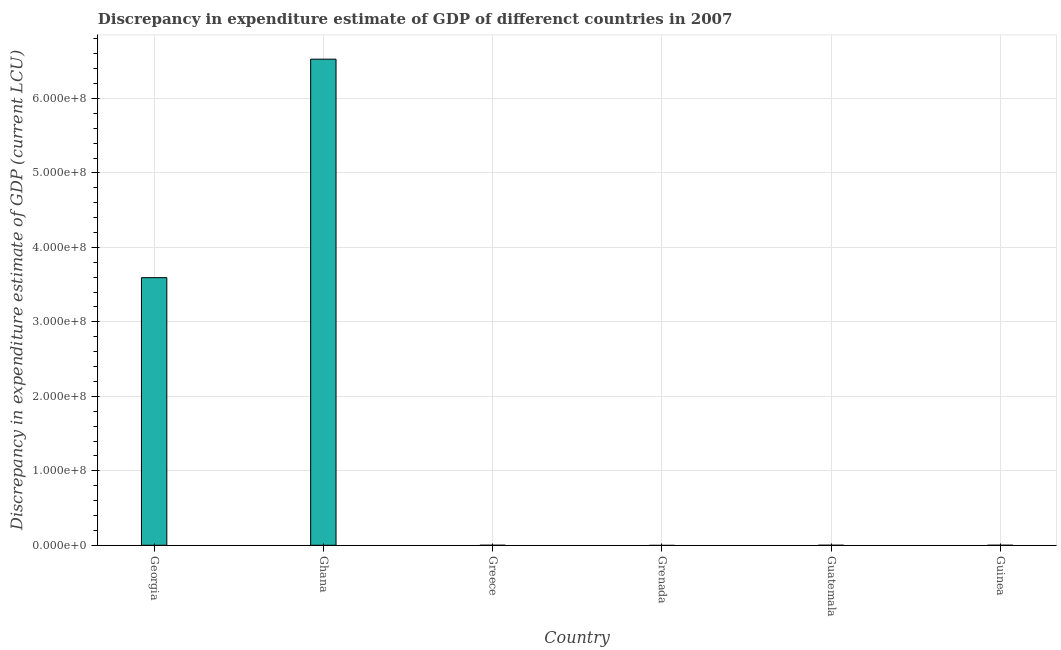What is the title of the graph?
Make the answer very short. Discrepancy in expenditure estimate of GDP of differenct countries in 2007. What is the label or title of the X-axis?
Give a very brief answer. Country. What is the label or title of the Y-axis?
Make the answer very short. Discrepancy in expenditure estimate of GDP (current LCU). Across all countries, what is the maximum discrepancy in expenditure estimate of gdp?
Your answer should be very brief. 6.53e+08. What is the sum of the discrepancy in expenditure estimate of gdp?
Offer a terse response. 1.01e+09. What is the difference between the discrepancy in expenditure estimate of gdp in Georgia and Greece?
Make the answer very short. 3.59e+08. What is the average discrepancy in expenditure estimate of gdp per country?
Your answer should be very brief. 1.69e+08. What is the median discrepancy in expenditure estimate of gdp?
Provide a succinct answer. 50. In how many countries, is the discrepancy in expenditure estimate of gdp greater than 600000000 LCU?
Make the answer very short. 1. What is the ratio of the discrepancy in expenditure estimate of gdp in Greece to that in Guatemala?
Offer a very short reply. 8.70e+05. Is the difference between the discrepancy in expenditure estimate of gdp in Georgia and Greece greater than the difference between any two countries?
Provide a short and direct response. No. What is the difference between the highest and the second highest discrepancy in expenditure estimate of gdp?
Offer a terse response. 2.93e+08. What is the difference between the highest and the lowest discrepancy in expenditure estimate of gdp?
Your response must be concise. 6.53e+08. What is the difference between two consecutive major ticks on the Y-axis?
Your answer should be compact. 1.00e+08. Are the values on the major ticks of Y-axis written in scientific E-notation?
Your answer should be very brief. Yes. What is the Discrepancy in expenditure estimate of GDP (current LCU) of Georgia?
Your answer should be very brief. 3.59e+08. What is the Discrepancy in expenditure estimate of GDP (current LCU) in Ghana?
Your answer should be compact. 6.53e+08. What is the Discrepancy in expenditure estimate of GDP (current LCU) in Guatemala?
Your answer should be compact. 0. What is the difference between the Discrepancy in expenditure estimate of GDP (current LCU) in Georgia and Ghana?
Your response must be concise. -2.93e+08. What is the difference between the Discrepancy in expenditure estimate of GDP (current LCU) in Georgia and Greece?
Offer a terse response. 3.59e+08. What is the difference between the Discrepancy in expenditure estimate of GDP (current LCU) in Georgia and Guatemala?
Offer a very short reply. 3.59e+08. What is the difference between the Discrepancy in expenditure estimate of GDP (current LCU) in Ghana and Greece?
Provide a succinct answer. 6.53e+08. What is the difference between the Discrepancy in expenditure estimate of GDP (current LCU) in Ghana and Guatemala?
Your response must be concise. 6.53e+08. What is the difference between the Discrepancy in expenditure estimate of GDP (current LCU) in Greece and Guatemala?
Give a very brief answer. 100. What is the ratio of the Discrepancy in expenditure estimate of GDP (current LCU) in Georgia to that in Ghana?
Make the answer very short. 0.55. What is the ratio of the Discrepancy in expenditure estimate of GDP (current LCU) in Georgia to that in Greece?
Your answer should be very brief. 3.59e+06. What is the ratio of the Discrepancy in expenditure estimate of GDP (current LCU) in Georgia to that in Guatemala?
Offer a terse response. 3.12e+12. What is the ratio of the Discrepancy in expenditure estimate of GDP (current LCU) in Ghana to that in Greece?
Make the answer very short. 6.53e+06. What is the ratio of the Discrepancy in expenditure estimate of GDP (current LCU) in Ghana to that in Guatemala?
Offer a terse response. 5.68e+12. What is the ratio of the Discrepancy in expenditure estimate of GDP (current LCU) in Greece to that in Guatemala?
Offer a very short reply. 8.70e+05. 